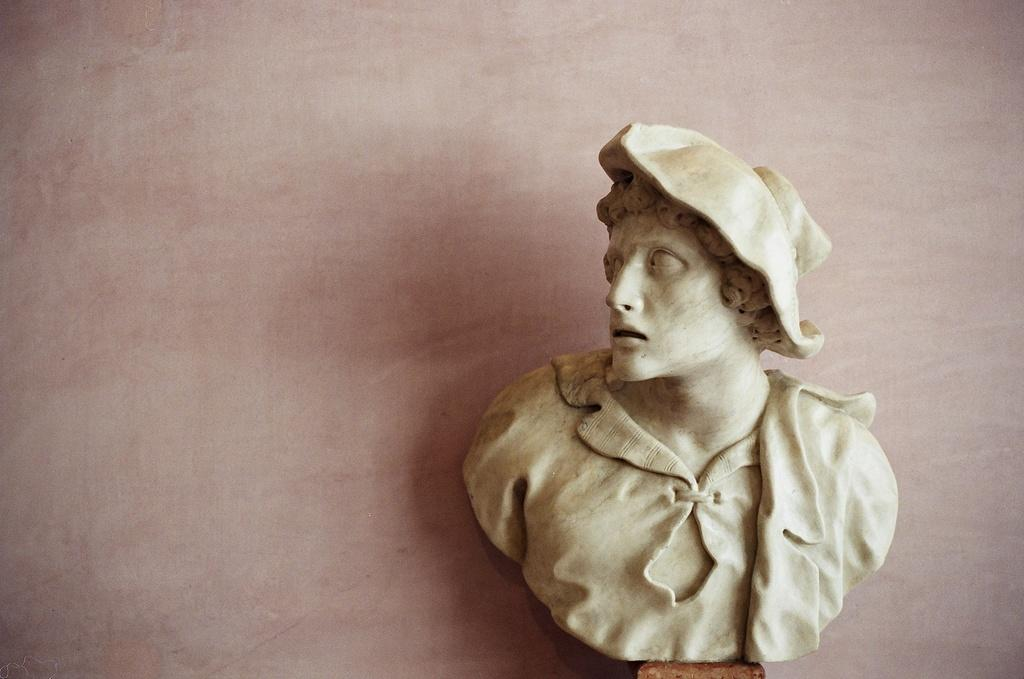What type of artwork is depicted in the image? There is a sculpture of a half person in the image. What can be seen in the background of the image? There is a wall in the background of the image. Where is the kettle located in the image? There is no kettle present in the image. What type of station is visible in the image? There is no station present in the image. 